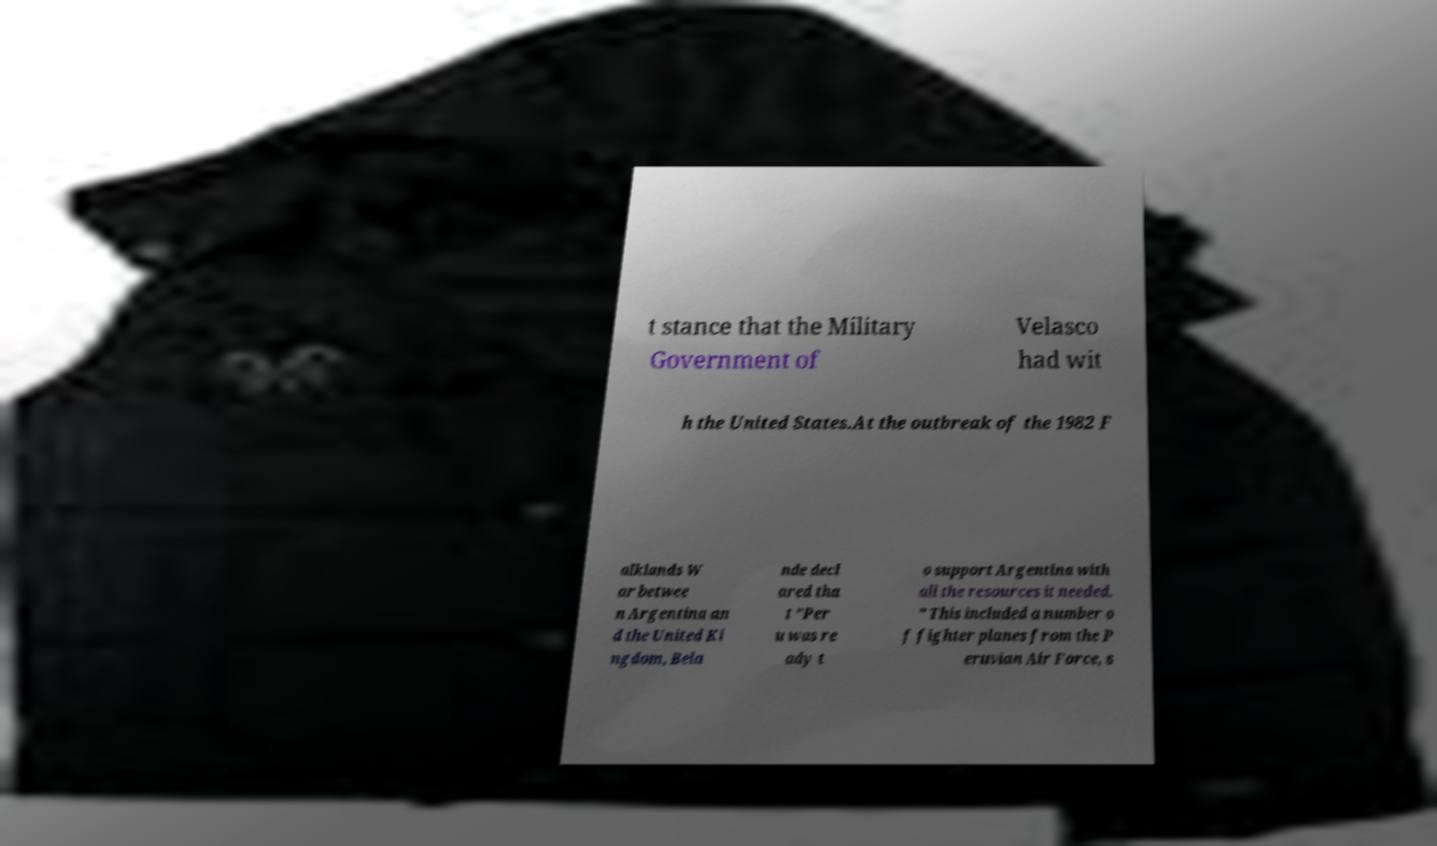Could you assist in decoding the text presented in this image and type it out clearly? t stance that the Military Government of Velasco had wit h the United States.At the outbreak of the 1982 F alklands W ar betwee n Argentina an d the United Ki ngdom, Bela nde decl ared tha t "Per u was re ady t o support Argentina with all the resources it needed. " This included a number o f fighter planes from the P eruvian Air Force, s 